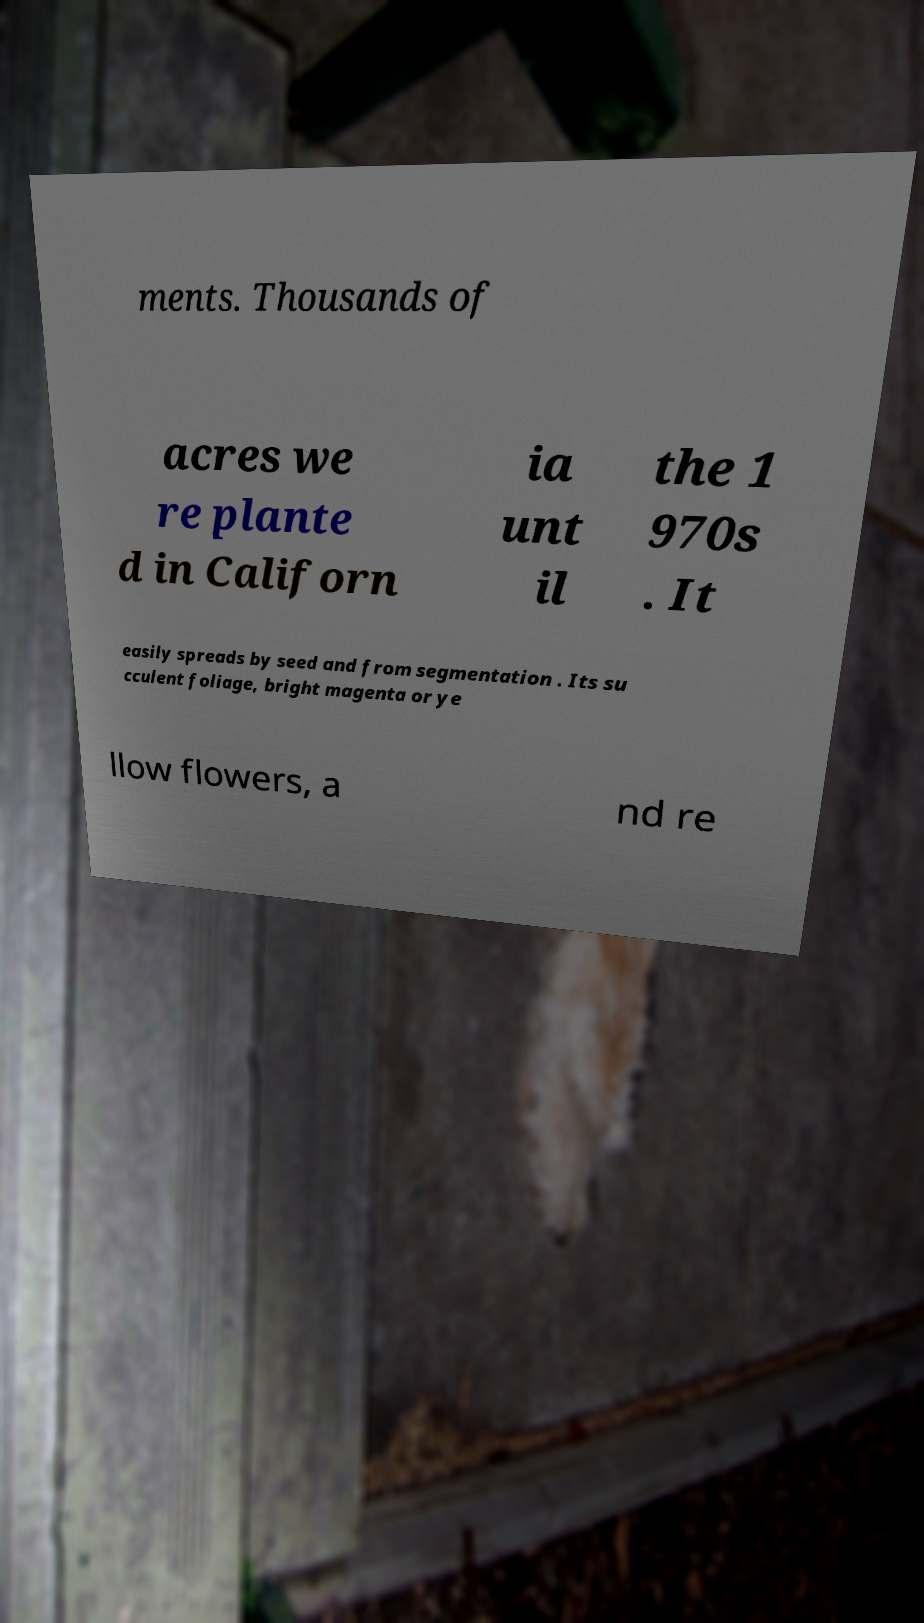Could you extract and type out the text from this image? ments. Thousands of acres we re plante d in Californ ia unt il the 1 970s . It easily spreads by seed and from segmentation . Its su cculent foliage, bright magenta or ye llow flowers, a nd re 